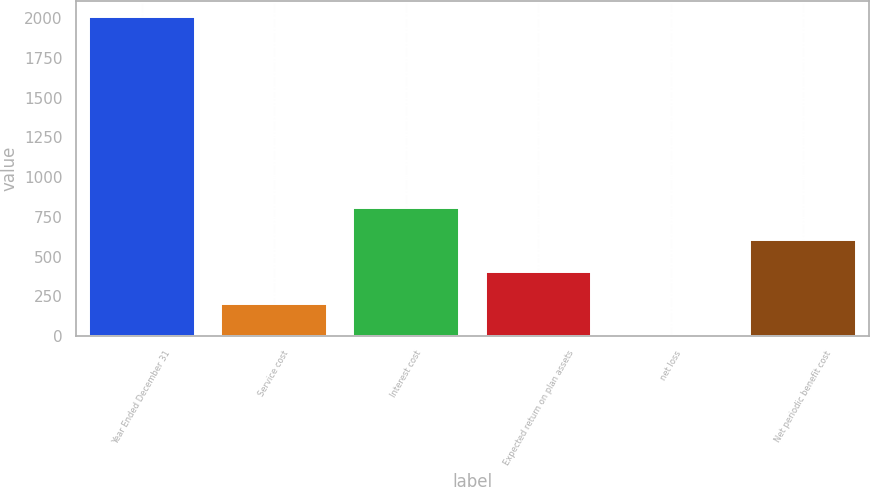Convert chart. <chart><loc_0><loc_0><loc_500><loc_500><bar_chart><fcel>Year Ended December 31<fcel>Service cost<fcel>Interest cost<fcel>Expected return on plan assets<fcel>net loss<fcel>Net periodic benefit cost<nl><fcel>2008<fcel>201.7<fcel>803.8<fcel>402.4<fcel>1<fcel>603.1<nl></chart> 